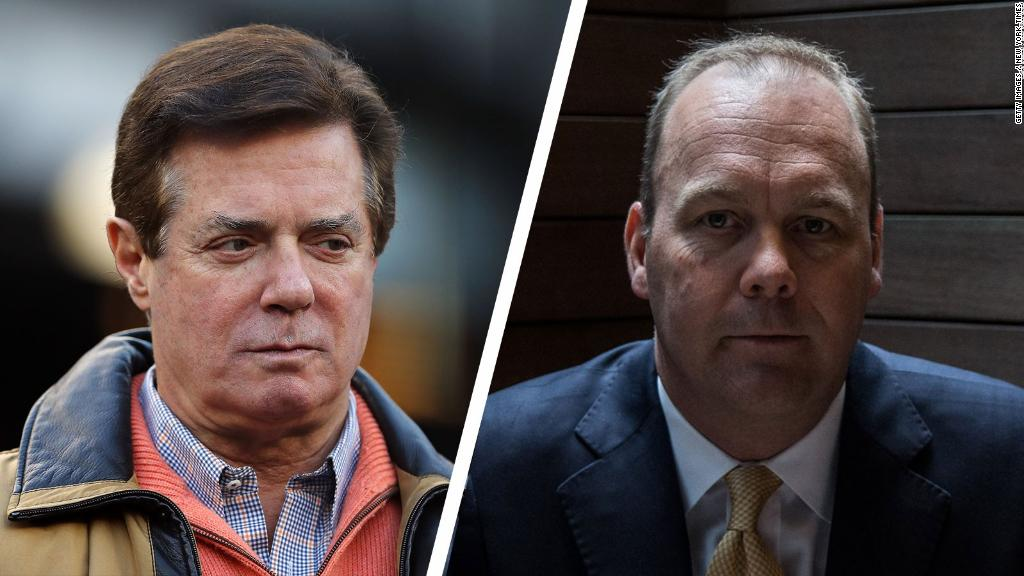Describe a detailed backstory for these two individuals. The man on the left, let's call him John, grew up in a small town where he always dreamed of making it big in the tech industry. After years of hard work, he founded a successful startup that developed groundbreaking software. His casual yet smart attire reflects his innovative spirit and leadership style that fosters a relaxed yet productive work environment.

The man on the right, named David, came from a family of lawyers. Following in his family's footsteps, he became a renowned corporate lawyer. His impeccable suit and tie symbolize his dedication to his profession and the high standards he sets for himself. Known for his sharp mind and strategic thinking, David often handles complex legal matters for multinational corporations. Their paths crossed when John's company needed legal counsel for a major merger, bringing together their distinct yet complementary expertise. Imagine these two characters were involved in a spy thriller. What roles would they play? In a spy thriller, John could be the genius tech inventor whose latest creation has become the target of multiple intelligence agencies. His ability to innovate under pressure and think outside the box makes him pivotal in devising strategies to outmaneuver the antagonists.

David, on the other hand, could play the role of a high-level intelligence officer. His sharp mind and authoritative presence suit him for managing covert operations. The two of them would form an unlikely but formidable team, combining John's technical prowess with David's strategic acumen to uncover a conspiracy that threatens global security. 